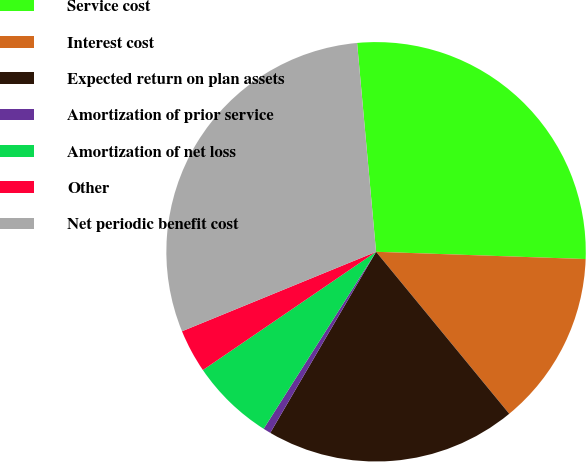Convert chart to OTSL. <chart><loc_0><loc_0><loc_500><loc_500><pie_chart><fcel>Service cost<fcel>Interest cost<fcel>Expected return on plan assets<fcel>Amortization of prior service<fcel>Amortization of net loss<fcel>Other<fcel>Net periodic benefit cost<nl><fcel>27.0%<fcel>13.5%<fcel>19.37%<fcel>0.59%<fcel>6.46%<fcel>3.35%<fcel>29.75%<nl></chart> 